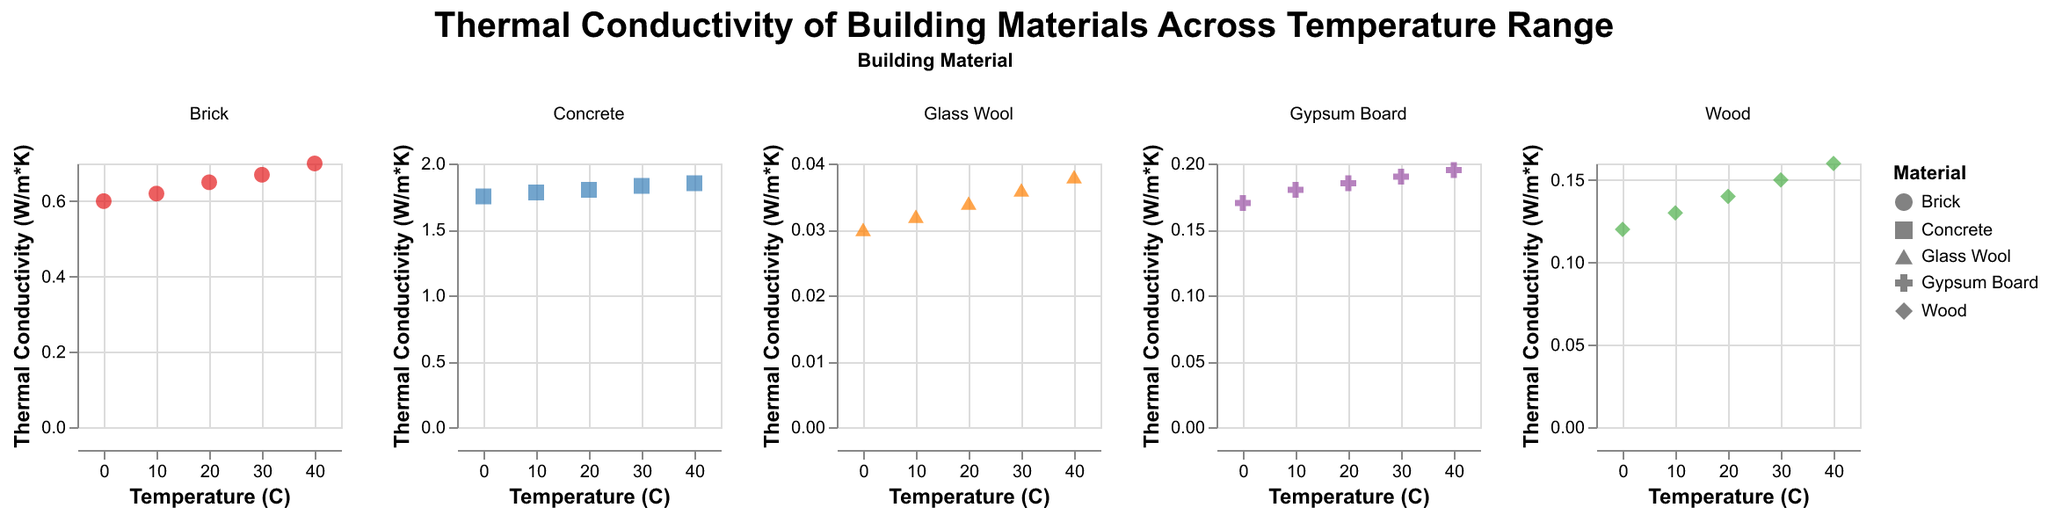What's the title of the plot? The title is displayed at the top center of the figure and reads: "Thermal Conductivity of Building Materials Across Temperature Range".
Answer: Thermal Conductivity of Building Materials Across Temperature Range How many building materials are compared in the plot? The plot facets by building material, and there are 5 distinct panels, each representing one building material: Brick, Wood, Concrete, Glass Wool, Gypsum Board.
Answer: 5 Which material has the lowest thermal conductivity at 0°C? By observing each subplot at the point corresponding to 0°C on the x-axis, Glass Wool has the lowest value on the y-axis, indicating its thermal conductivity.
Answer: Glass Wool Which material shows the highest increase in thermal conductivity from 0°C to 40°C? Calculating the differences in thermal conductivity between 0°C and 40°C for each material: Brick (0.7 - 0.6 = 0.1), Wood (0.16 - 0.12 = 0.04), Concrete (1.85 - 1.75 = 0.1), Glass Wool (0.038 - 0.03 = 0.008), Gypsum Board (0.195 - 0.17 = 0.025). Brick and Concrete both exhibit the highest increase (0.1).
Answer: Brick and Concrete What is the thermal conductivity of Wood at 20°C? Locate the specific point in the Wood subplot where Temperature (C) equals 20 and observe the y-axis value at that point. It shows 0.14 W/m*K.
Answer: 0.14 W/m*K Compare the thermal conductivity of Brick and Gypsum Board at 30°C. Which one is higher? Check the subplots for Brick and Gypsum Board at the point where Temperature (C) is 30; compare the y-axis values. Brick's value is 0.67 W/m*K, Gypsum Board's value is 0.19 W/m*K. Brick is higher.
Answer: Brick Between which temperatures does Glass Wool show the steepest increase in thermal conductivity? Look at the slope of the points in the Glass Wool subplot. The steeper the slope, the higher the rate of increase. The steepest increase is observed between 30°C and 40°C.
Answer: 30°C to 40°C Does Concrete's thermal conductivity always remain the highest among all materials at every temperature interval? By comparing the y-axis values of all subplots at each temperature interval (0°C, 10°C, 20°C, 30°C, 40°C), Concrete consistently shows the highest thermal conductivity.
Answer: Yes 